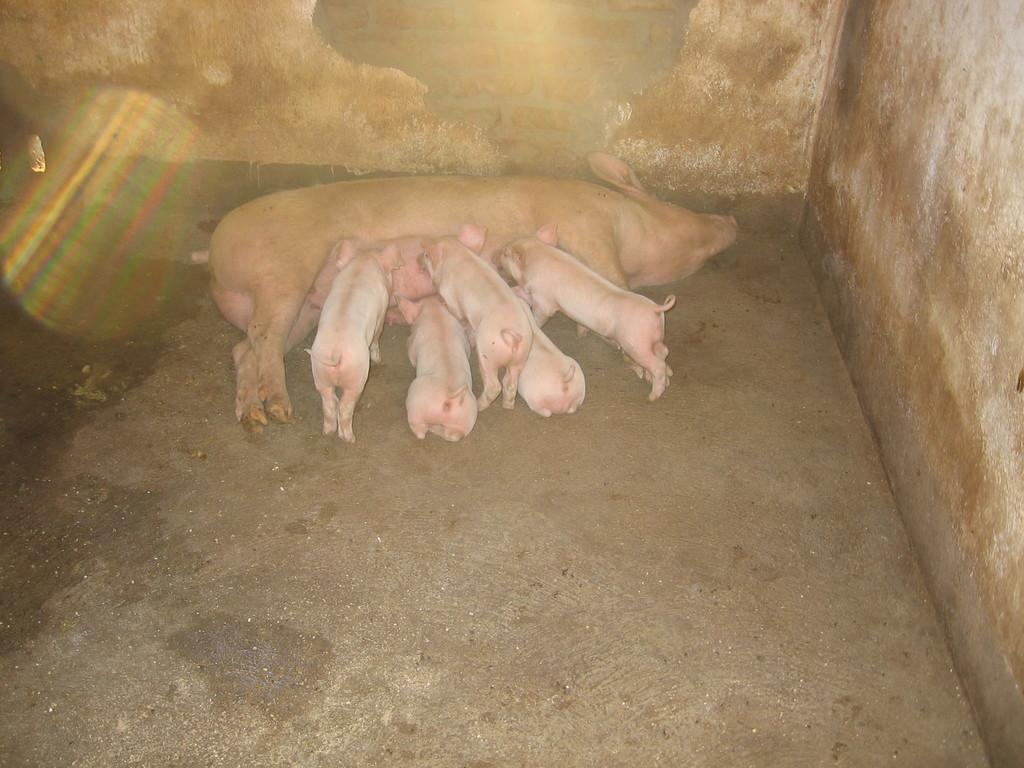What is at the bottom of the image? There is a pavement at the bottom of the image. What can be seen on the right side of the image? There is a wall on the right side of the image. What is the main subject in the middle of the image? There is a pig in the middle of the image. How many piglets are present in the image? There are five piglets in the image. What is visible in the background of the image? There is a wall in the background of the image. What type of rings can be seen on the manager's fingers in the image? There is no manager or rings present in the image; it features a pig and piglets. How do the piglets plan to attack the wall in the image? There is no indication of an attack in the image; the piglets are simply present with the pig. 